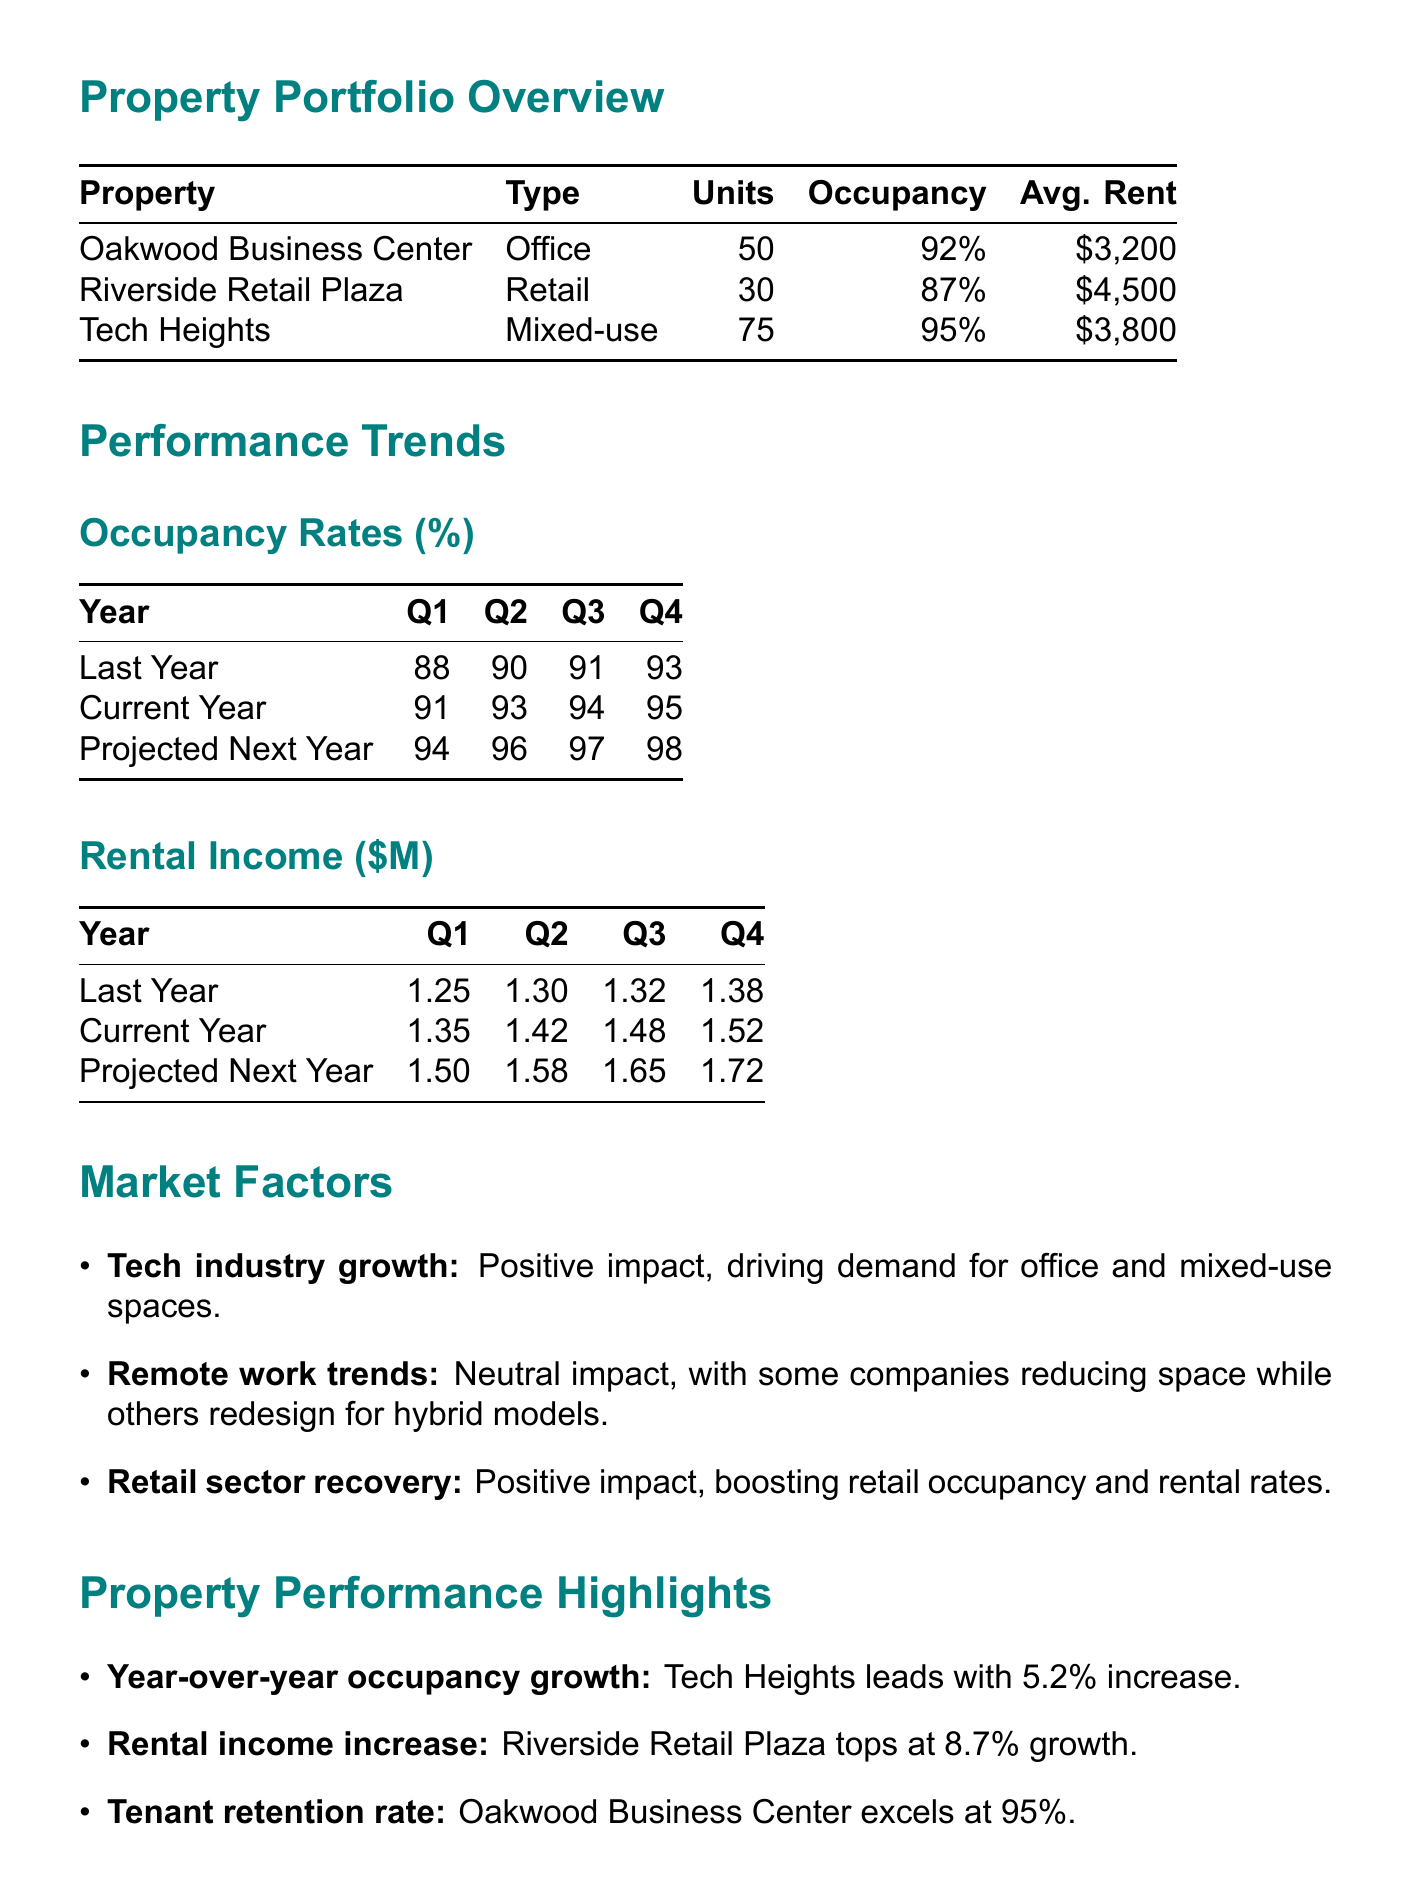What is the occupancy rate of Riverside Retail Plaza? The occupancy rate of Riverside Retail Plaza is 87%.
Answer: 87% Which property has the highest average rent? The property with the highest average rent is Riverside Retail Plaza at $4500.
Answer: $4500 What is the projected Q1 occupancy rate for next year? The projected Q1 occupancy rate for next year is 94%.
Answer: 94% Which property experienced the highest year-over-year occupancy growth? Tech Heights experienced the highest year-over-year occupancy growth at 5.2%.
Answer: Tech Heights What is the expected impact of sustainable building upgrades? The expected impact of sustainable building upgrades is to attract environmentally conscious tenants and potentially command higher rents.
Answer: Attract environmentally conscious tenants and potentially command higher rents 